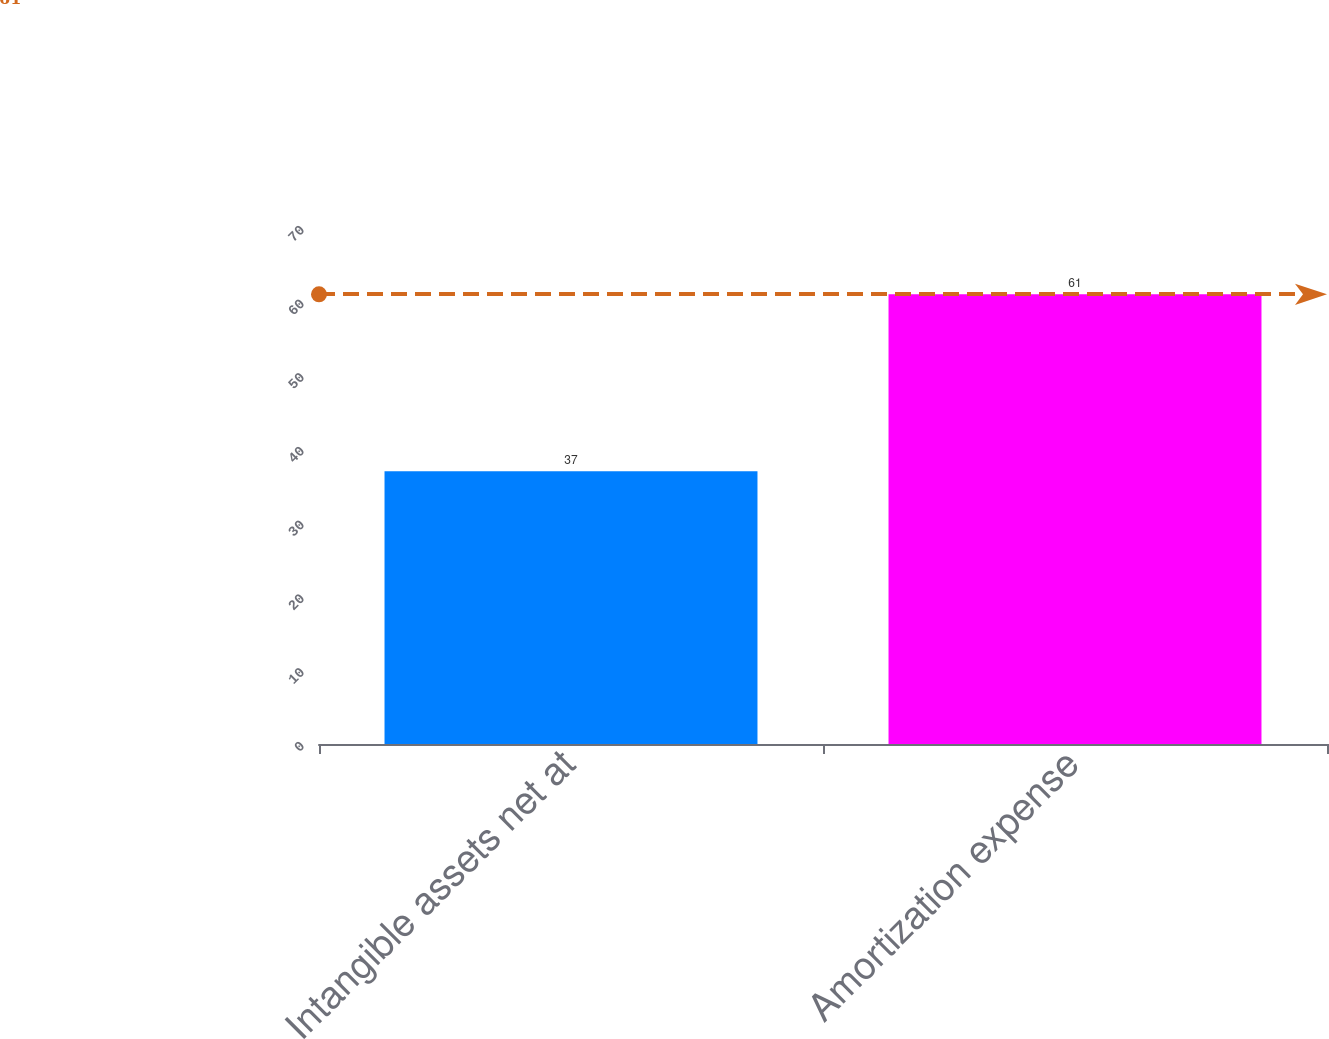Convert chart. <chart><loc_0><loc_0><loc_500><loc_500><bar_chart><fcel>Intangible assets net at<fcel>Amortization expense<nl><fcel>37<fcel>61<nl></chart> 